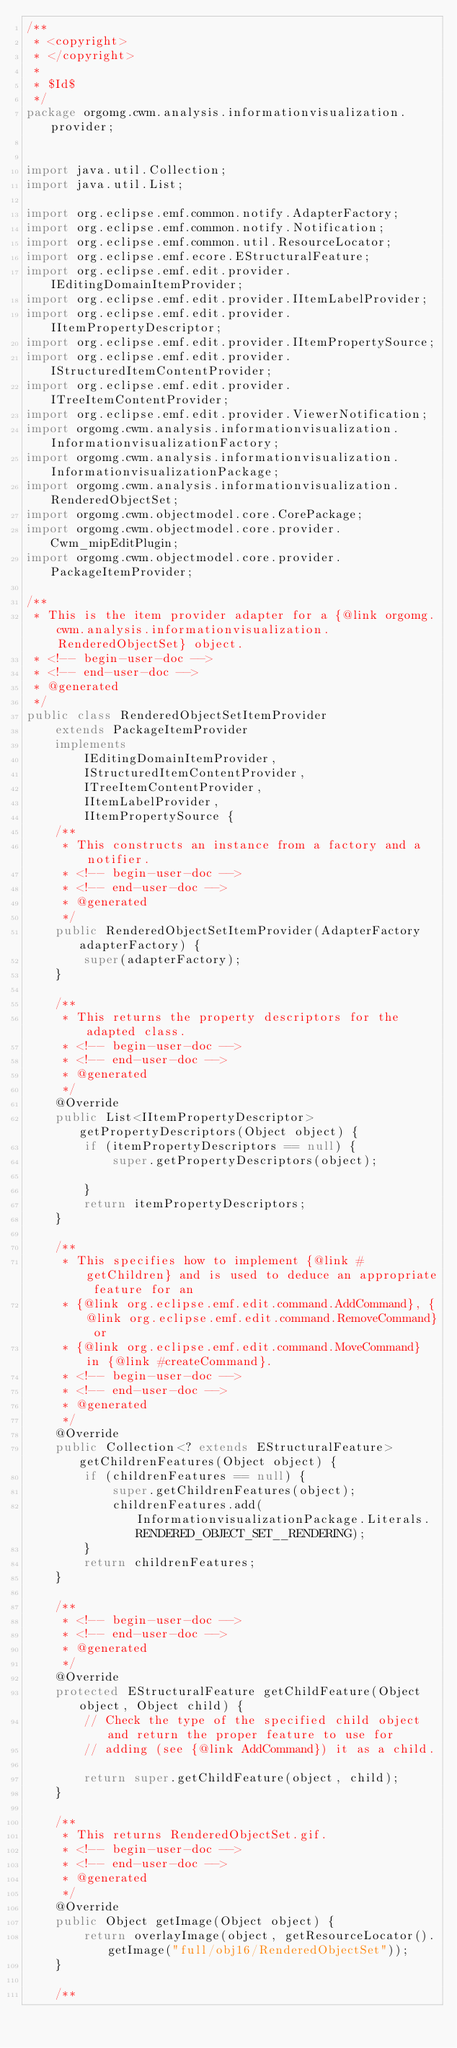<code> <loc_0><loc_0><loc_500><loc_500><_Java_>/**
 * <copyright>
 * </copyright>
 *
 * $Id$
 */
package orgomg.cwm.analysis.informationvisualization.provider;


import java.util.Collection;
import java.util.List;

import org.eclipse.emf.common.notify.AdapterFactory;
import org.eclipse.emf.common.notify.Notification;
import org.eclipse.emf.common.util.ResourceLocator;
import org.eclipse.emf.ecore.EStructuralFeature;
import org.eclipse.emf.edit.provider.IEditingDomainItemProvider;
import org.eclipse.emf.edit.provider.IItemLabelProvider;
import org.eclipse.emf.edit.provider.IItemPropertyDescriptor;
import org.eclipse.emf.edit.provider.IItemPropertySource;
import org.eclipse.emf.edit.provider.IStructuredItemContentProvider;
import org.eclipse.emf.edit.provider.ITreeItemContentProvider;
import org.eclipse.emf.edit.provider.ViewerNotification;
import orgomg.cwm.analysis.informationvisualization.InformationvisualizationFactory;
import orgomg.cwm.analysis.informationvisualization.InformationvisualizationPackage;
import orgomg.cwm.analysis.informationvisualization.RenderedObjectSet;
import orgomg.cwm.objectmodel.core.CorePackage;
import orgomg.cwm.objectmodel.core.provider.Cwm_mipEditPlugin;
import orgomg.cwm.objectmodel.core.provider.PackageItemProvider;

/**
 * This is the item provider adapter for a {@link orgomg.cwm.analysis.informationvisualization.RenderedObjectSet} object.
 * <!-- begin-user-doc -->
 * <!-- end-user-doc -->
 * @generated
 */
public class RenderedObjectSetItemProvider
    extends PackageItemProvider
    implements	
        IEditingDomainItemProvider,	
        IStructuredItemContentProvider,	
        ITreeItemContentProvider,	
        IItemLabelProvider,	
        IItemPropertySource {
    /**
     * This constructs an instance from a factory and a notifier.
     * <!-- begin-user-doc -->
     * <!-- end-user-doc -->
     * @generated
     */
    public RenderedObjectSetItemProvider(AdapterFactory adapterFactory) {
        super(adapterFactory);
    }

    /**
     * This returns the property descriptors for the adapted class.
     * <!-- begin-user-doc -->
     * <!-- end-user-doc -->
     * @generated
     */
    @Override
    public List<IItemPropertyDescriptor> getPropertyDescriptors(Object object) {
        if (itemPropertyDescriptors == null) {
            super.getPropertyDescriptors(object);

        }
        return itemPropertyDescriptors;
    }

    /**
     * This specifies how to implement {@link #getChildren} and is used to deduce an appropriate feature for an
     * {@link org.eclipse.emf.edit.command.AddCommand}, {@link org.eclipse.emf.edit.command.RemoveCommand} or
     * {@link org.eclipse.emf.edit.command.MoveCommand} in {@link #createCommand}.
     * <!-- begin-user-doc -->
     * <!-- end-user-doc -->
     * @generated
     */
    @Override
    public Collection<? extends EStructuralFeature> getChildrenFeatures(Object object) {
        if (childrenFeatures == null) {
            super.getChildrenFeatures(object);
            childrenFeatures.add(InformationvisualizationPackage.Literals.RENDERED_OBJECT_SET__RENDERING);
        }
        return childrenFeatures;
    }

    /**
     * <!-- begin-user-doc -->
     * <!-- end-user-doc -->
     * @generated
     */
    @Override
    protected EStructuralFeature getChildFeature(Object object, Object child) {
        // Check the type of the specified child object and return the proper feature to use for
        // adding (see {@link AddCommand}) it as a child.

        return super.getChildFeature(object, child);
    }

    /**
     * This returns RenderedObjectSet.gif.
     * <!-- begin-user-doc -->
     * <!-- end-user-doc -->
     * @generated
     */
    @Override
    public Object getImage(Object object) {
        return overlayImage(object, getResourceLocator().getImage("full/obj16/RenderedObjectSet"));
    }

    /**</code> 